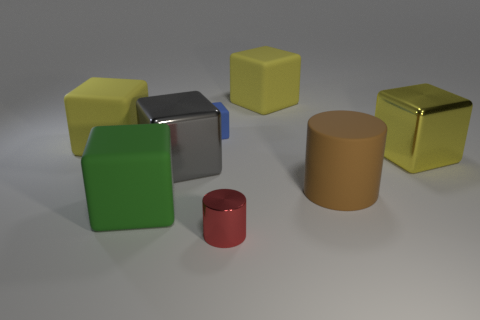Are there an equal number of blue things that are to the right of the large yellow metallic object and large brown rubber objects that are behind the brown object?
Keep it short and to the point. Yes. The metal object that is both behind the green block and to the right of the gray thing has what shape?
Give a very brief answer. Cube. What number of green cubes are right of the green block?
Your answer should be very brief. 0. How many other things are the same shape as the big yellow metal object?
Make the answer very short. 5. Are there fewer small red shiny objects than small purple shiny balls?
Provide a succinct answer. No. What is the size of the matte thing that is to the right of the red metal cylinder and behind the big brown cylinder?
Provide a succinct answer. Large. What size is the metal cube in front of the large yellow object that is right of the large yellow matte cube behind the blue thing?
Your response must be concise. Large. What size is the yellow metallic block?
Provide a short and direct response. Large. Is there anything else that has the same material as the brown thing?
Ensure brevity in your answer.  Yes. There is a big metal cube that is behind the metallic cube that is left of the shiny cylinder; are there any large cylinders that are in front of it?
Your answer should be very brief. Yes. 